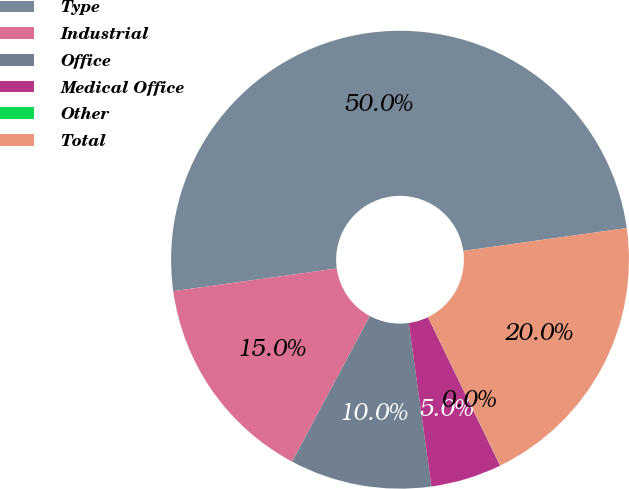Convert chart to OTSL. <chart><loc_0><loc_0><loc_500><loc_500><pie_chart><fcel>Type<fcel>Industrial<fcel>Office<fcel>Medical Office<fcel>Other<fcel>Total<nl><fcel>49.99%<fcel>15.0%<fcel>10.0%<fcel>5.01%<fcel>0.01%<fcel>20.0%<nl></chart> 